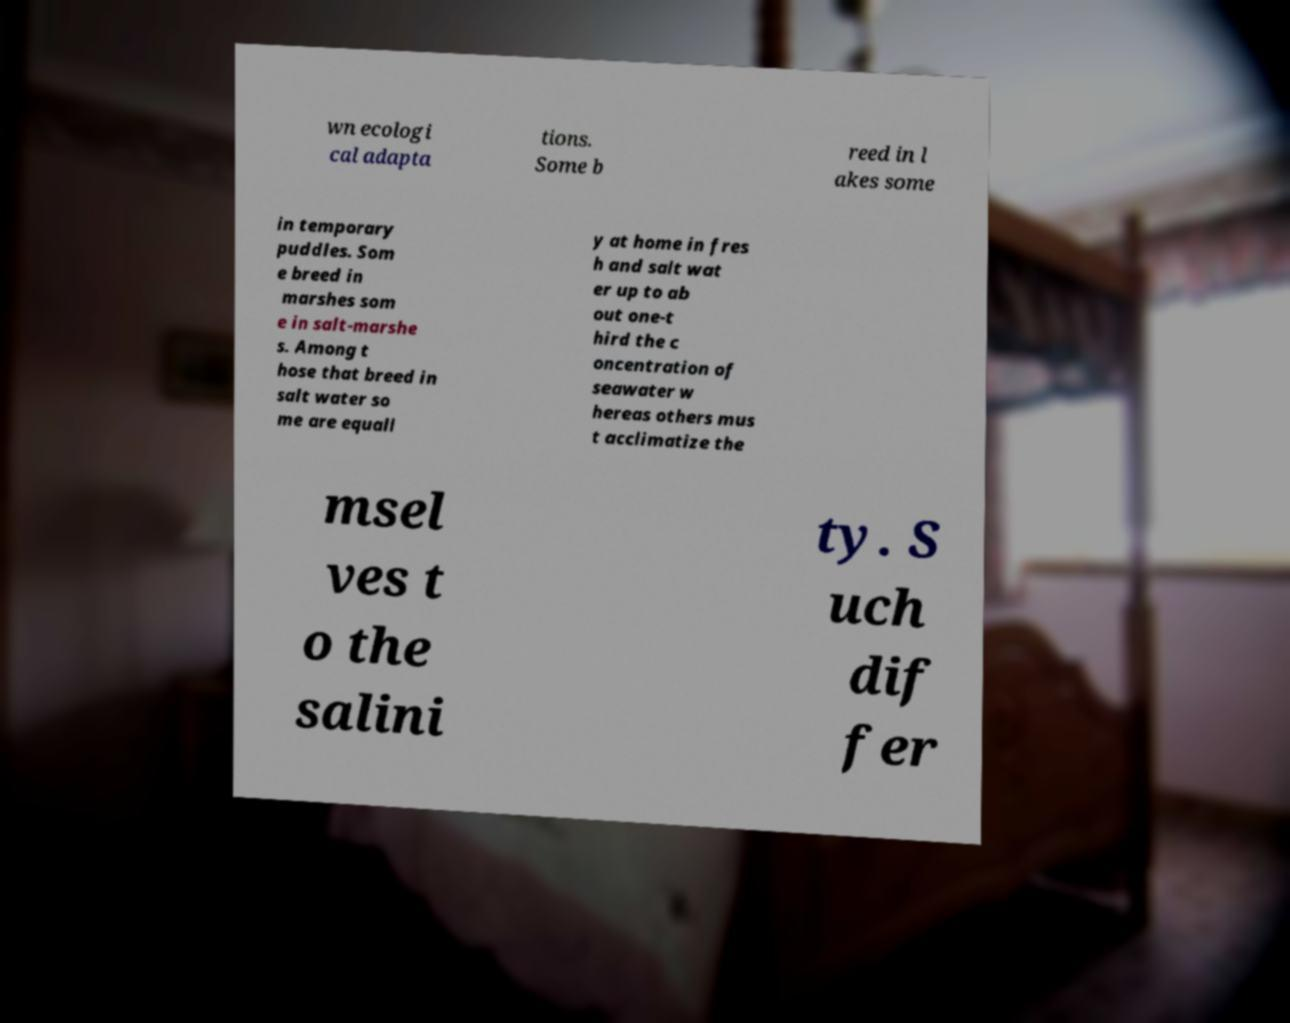Please identify and transcribe the text found in this image. wn ecologi cal adapta tions. Some b reed in l akes some in temporary puddles. Som e breed in marshes som e in salt-marshe s. Among t hose that breed in salt water so me are equall y at home in fres h and salt wat er up to ab out one-t hird the c oncentration of seawater w hereas others mus t acclimatize the msel ves t o the salini ty. S uch dif fer 